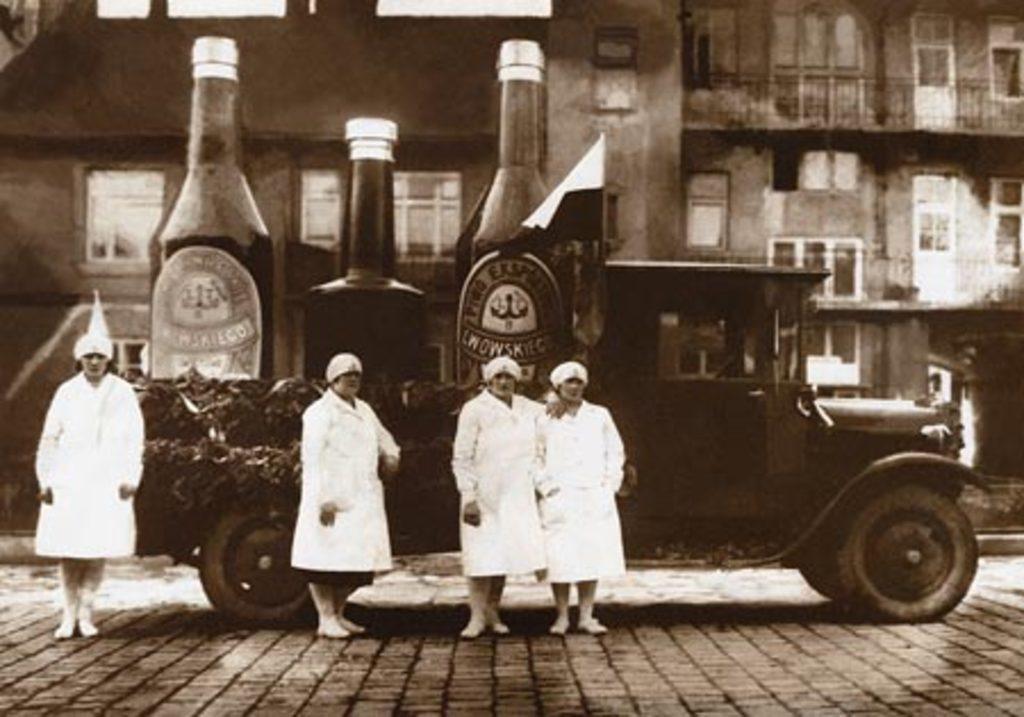Can you describe this image briefly? In this picture there are four persons who are wearing white dress and they are standing near to the truck. On the truck I can see the three big wine bottles and flag. In the background I can see the buildings. On the right I can see the windows and doors. At the top there is a sky. 